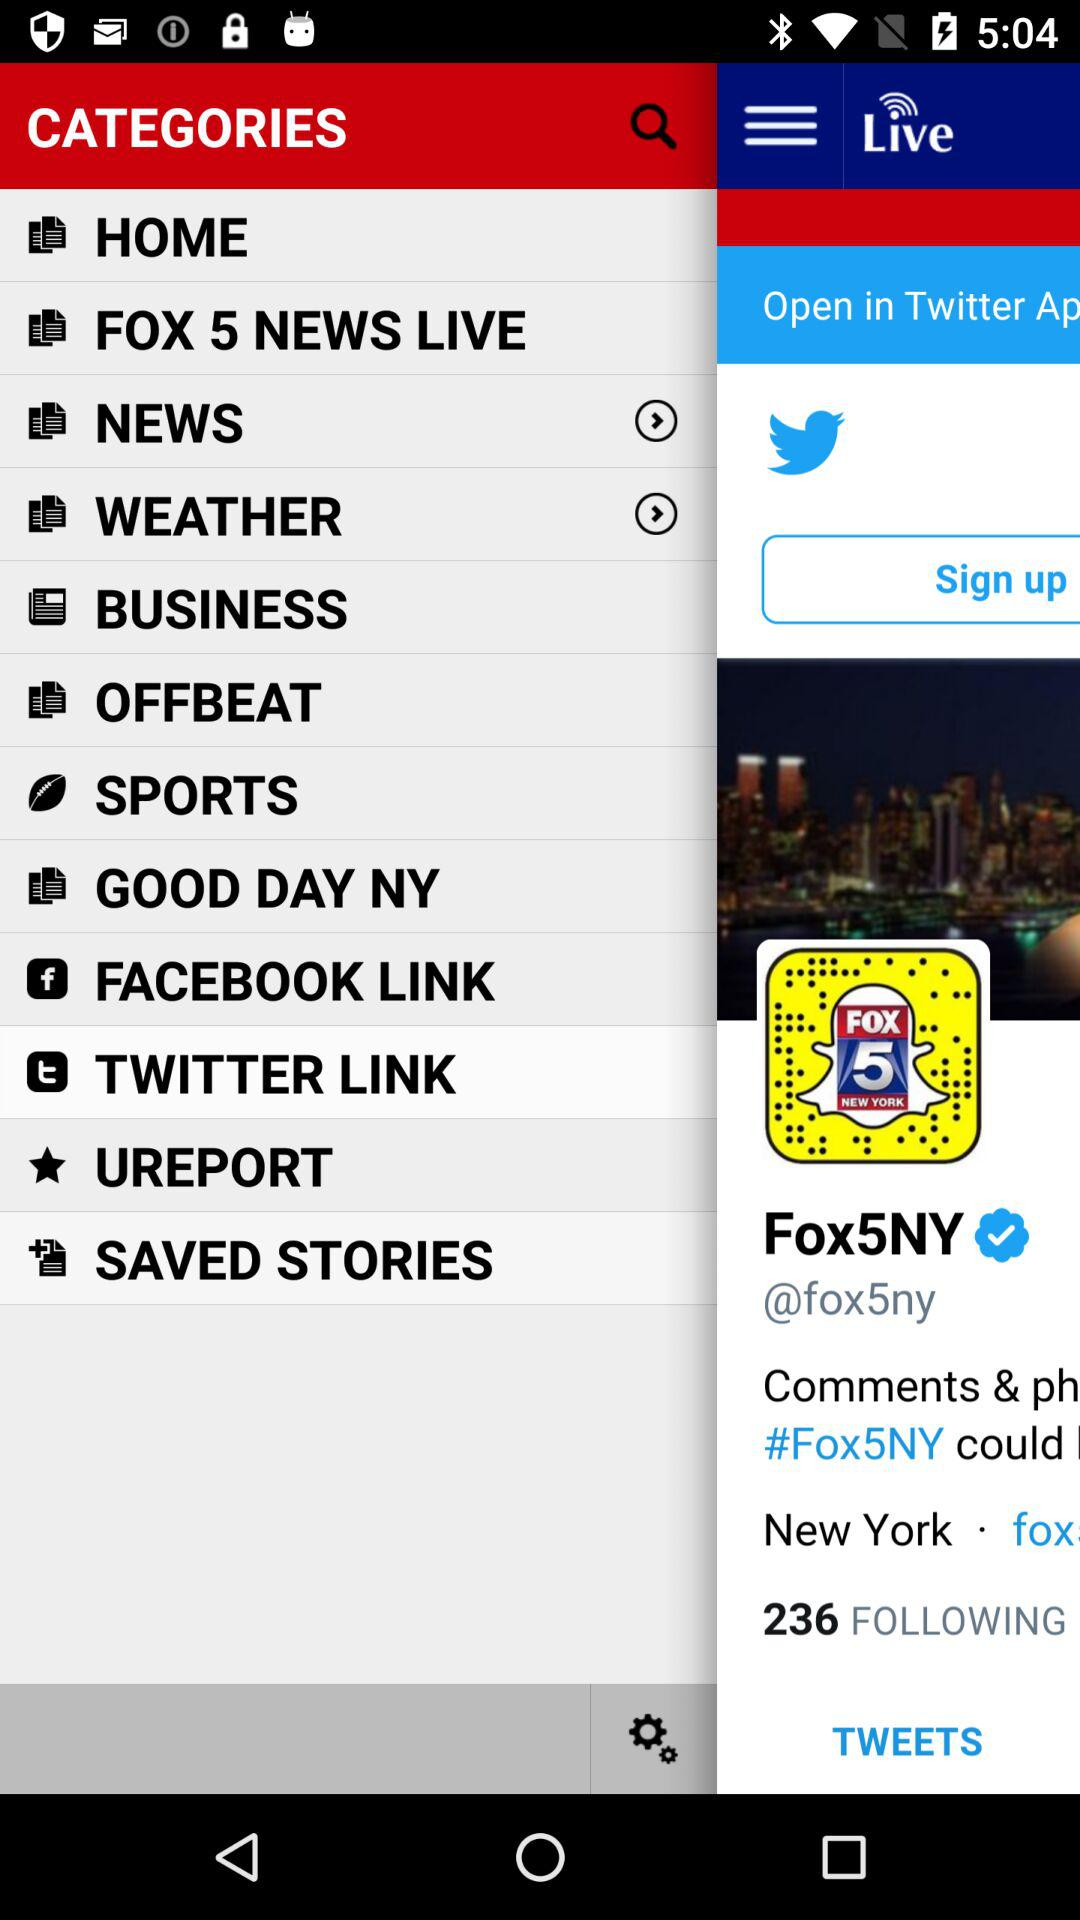How many people is "Fox5NY" following? "Fox5NY" is following 236 people. 